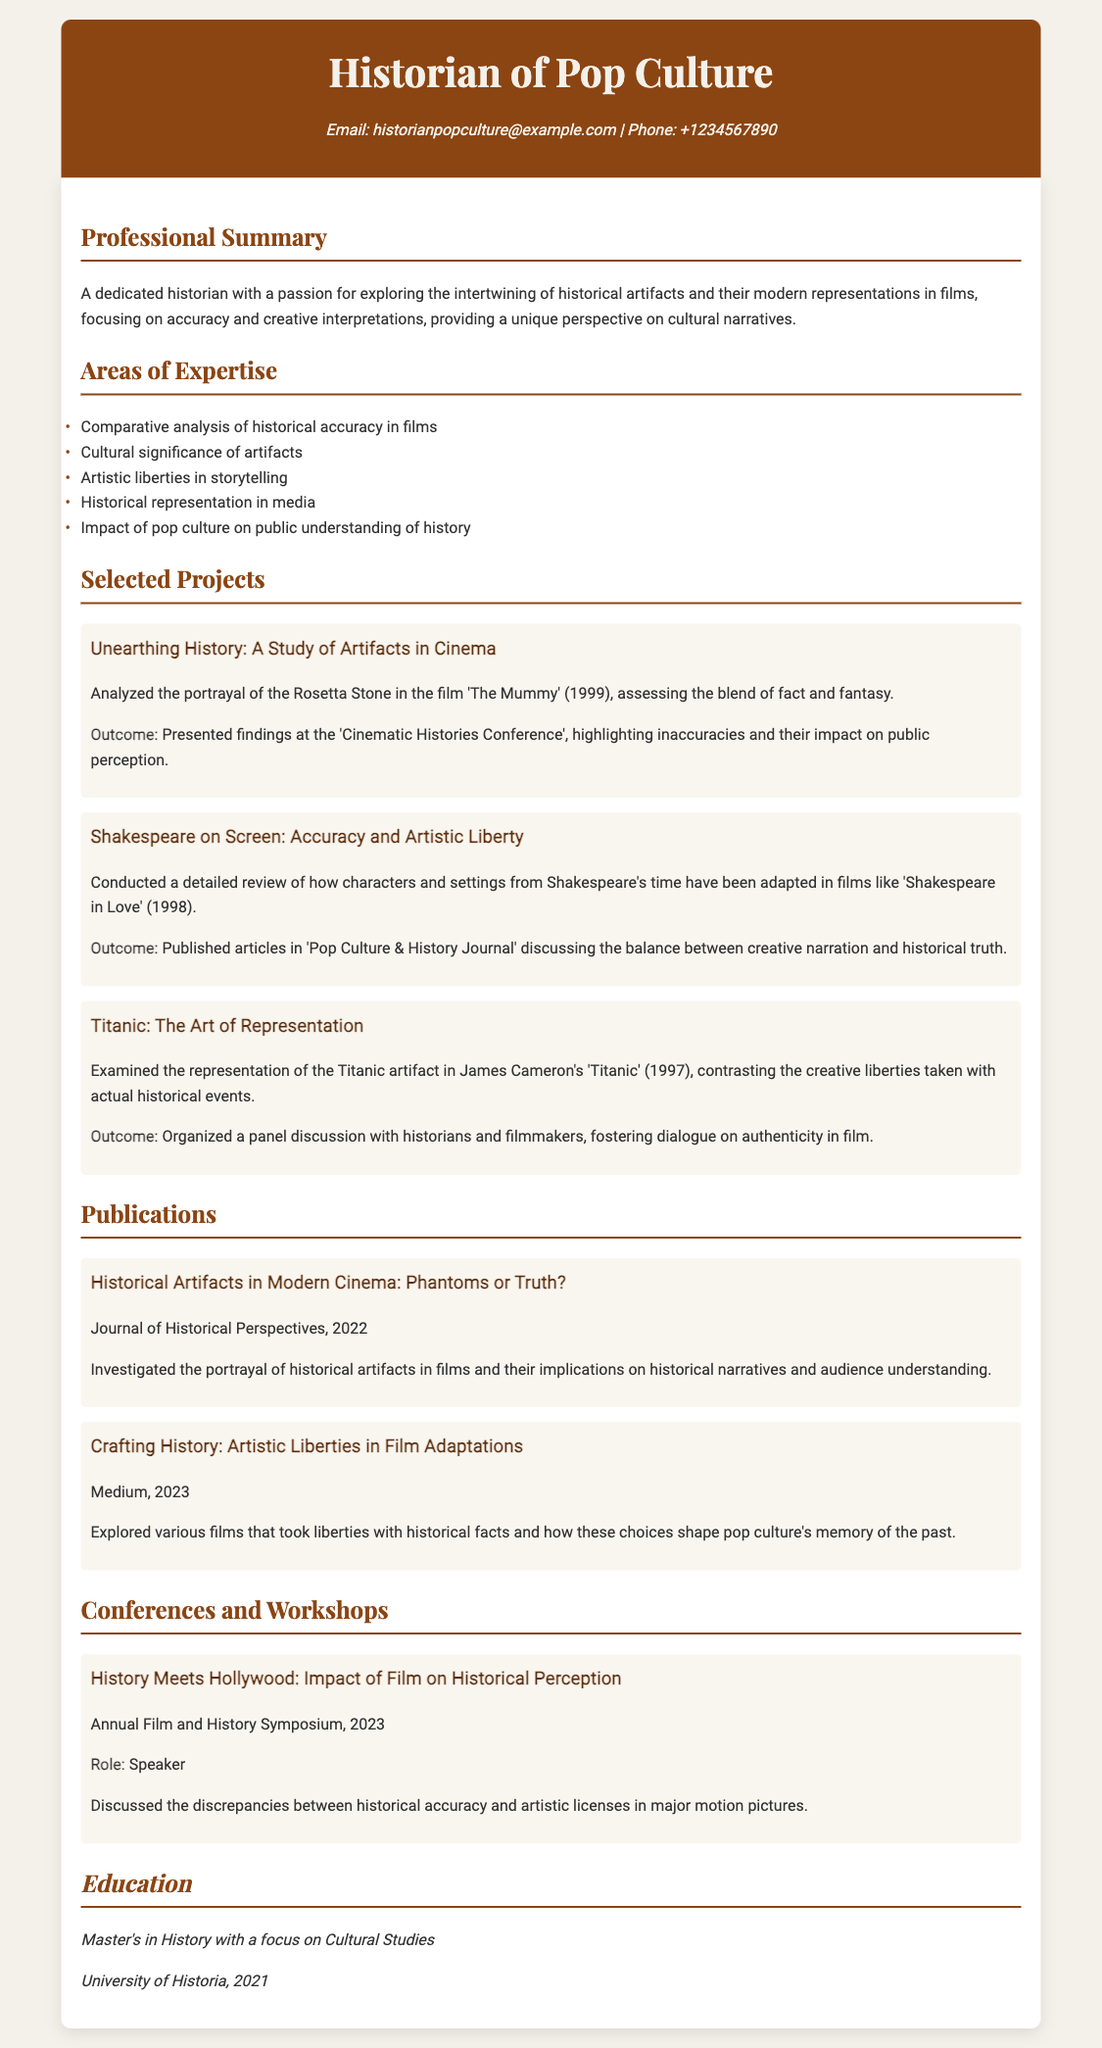What is the email address provided? The email address is mentioned directly in the contact information section of the document.
Answer: historianpopculture@example.com What is the title of the publication from 2022? This publication is highlighted in the publications section, indicating its completion year directly after the title.
Answer: Historical Artifacts in Modern Cinema: Phantoms or Truth? Who conducted the project 'Titanic: The Art of Representation'? The author of the CV is implicitly identified as the person conducting the listed projects.
Answer: Historian of Pop Culture What year did the historian complete their Master's degree? The graduation year is stated in the education section as part of the educational background of the historian.
Answer: 2021 What major event was the speaker role at the 2023 Annual Film and History Symposium? The conference section cites the major topic discussed along with the event's name and year.
Answer: History Meets Hollywood: Impact of Film on Historical Perception In which journal was the article on artistic liberties published? The name of the journal is clearly indicated alongside the publication entry for 2023 in the document.
Answer: Medium How many selected projects are detailed in the CV? A count of the listed projects in the selected projects section will answer this question.
Answer: Three What is one area of expertise mentioned? Identifying areas of expertise based on the listed items under the Areas of Expertise section will provide the answer.
Answer: Comparative analysis of historical accuracy in films 